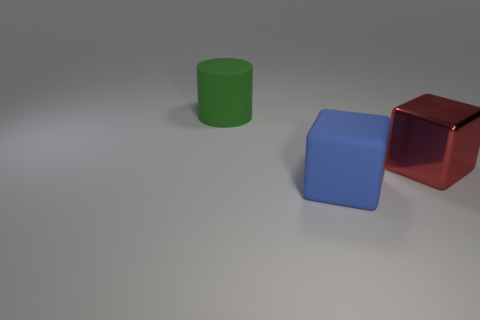Subtract all purple cubes. Subtract all red spheres. How many cubes are left? 2 Add 1 blue objects. How many objects exist? 4 Subtract all cylinders. How many objects are left? 2 Subtract all small red metallic balls. Subtract all large green matte objects. How many objects are left? 2 Add 3 large cylinders. How many large cylinders are left? 4 Add 3 big green matte objects. How many big green matte objects exist? 4 Subtract 0 cyan balls. How many objects are left? 3 